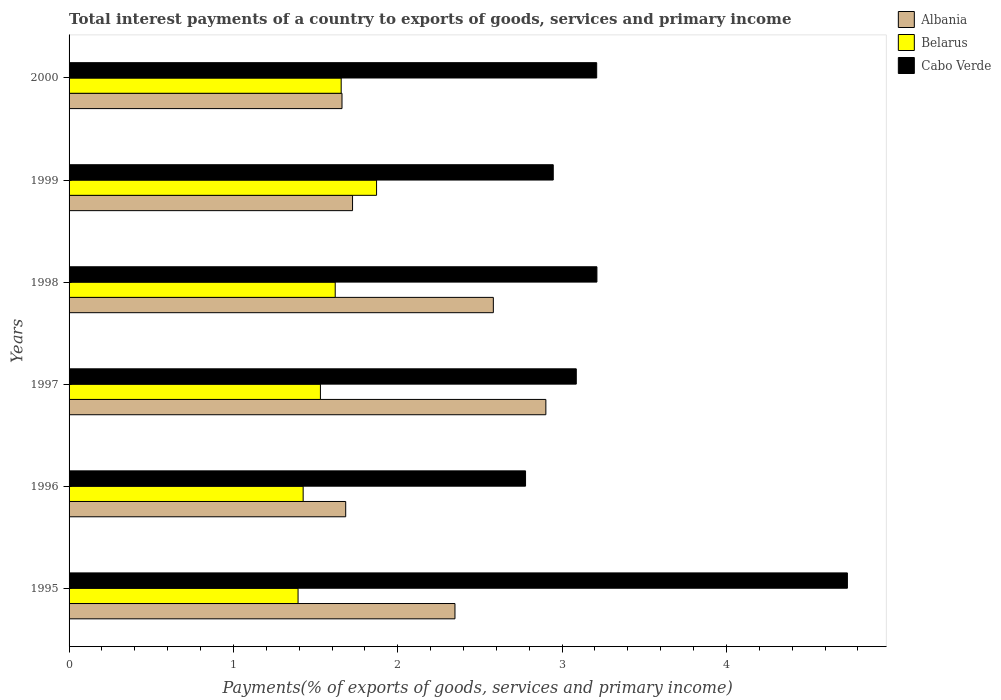How many groups of bars are there?
Your answer should be compact. 6. Are the number of bars per tick equal to the number of legend labels?
Your answer should be compact. Yes. How many bars are there on the 2nd tick from the bottom?
Provide a succinct answer. 3. In how many cases, is the number of bars for a given year not equal to the number of legend labels?
Offer a very short reply. 0. What is the total interest payments in Cabo Verde in 1997?
Your answer should be compact. 3.09. Across all years, what is the maximum total interest payments in Belarus?
Ensure brevity in your answer.  1.87. Across all years, what is the minimum total interest payments in Albania?
Your answer should be very brief. 1.66. In which year was the total interest payments in Belarus maximum?
Offer a very short reply. 1999. In which year was the total interest payments in Albania minimum?
Provide a succinct answer. 2000. What is the total total interest payments in Belarus in the graph?
Give a very brief answer. 9.49. What is the difference between the total interest payments in Cabo Verde in 1995 and that in 1998?
Your response must be concise. 1.52. What is the difference between the total interest payments in Cabo Verde in 2000 and the total interest payments in Albania in 1999?
Offer a terse response. 1.49. What is the average total interest payments in Cabo Verde per year?
Offer a very short reply. 3.33. In the year 1998, what is the difference between the total interest payments in Cabo Verde and total interest payments in Belarus?
Provide a short and direct response. 1.59. What is the ratio of the total interest payments in Cabo Verde in 1996 to that in 1998?
Provide a succinct answer. 0.86. What is the difference between the highest and the second highest total interest payments in Belarus?
Your answer should be compact. 0.22. What is the difference between the highest and the lowest total interest payments in Cabo Verde?
Make the answer very short. 1.96. Is the sum of the total interest payments in Albania in 1996 and 1997 greater than the maximum total interest payments in Cabo Verde across all years?
Your response must be concise. No. What does the 3rd bar from the top in 1996 represents?
Make the answer very short. Albania. What does the 2nd bar from the bottom in 1997 represents?
Make the answer very short. Belarus. Is it the case that in every year, the sum of the total interest payments in Belarus and total interest payments in Cabo Verde is greater than the total interest payments in Albania?
Make the answer very short. Yes. How many years are there in the graph?
Ensure brevity in your answer.  6. What is the difference between two consecutive major ticks on the X-axis?
Offer a very short reply. 1. Are the values on the major ticks of X-axis written in scientific E-notation?
Your answer should be very brief. No. Does the graph contain any zero values?
Your answer should be very brief. No. How many legend labels are there?
Provide a short and direct response. 3. How are the legend labels stacked?
Ensure brevity in your answer.  Vertical. What is the title of the graph?
Make the answer very short. Total interest payments of a country to exports of goods, services and primary income. Does "Nigeria" appear as one of the legend labels in the graph?
Your answer should be very brief. No. What is the label or title of the X-axis?
Provide a succinct answer. Payments(% of exports of goods, services and primary income). What is the label or title of the Y-axis?
Provide a succinct answer. Years. What is the Payments(% of exports of goods, services and primary income) in Albania in 1995?
Give a very brief answer. 2.35. What is the Payments(% of exports of goods, services and primary income) of Belarus in 1995?
Your response must be concise. 1.39. What is the Payments(% of exports of goods, services and primary income) in Cabo Verde in 1995?
Ensure brevity in your answer.  4.74. What is the Payments(% of exports of goods, services and primary income) of Albania in 1996?
Provide a succinct answer. 1.68. What is the Payments(% of exports of goods, services and primary income) of Belarus in 1996?
Provide a succinct answer. 1.42. What is the Payments(% of exports of goods, services and primary income) in Cabo Verde in 1996?
Offer a very short reply. 2.78. What is the Payments(% of exports of goods, services and primary income) in Albania in 1997?
Offer a very short reply. 2.9. What is the Payments(% of exports of goods, services and primary income) in Belarus in 1997?
Offer a terse response. 1.53. What is the Payments(% of exports of goods, services and primary income) of Cabo Verde in 1997?
Offer a very short reply. 3.09. What is the Payments(% of exports of goods, services and primary income) of Albania in 1998?
Your answer should be compact. 2.58. What is the Payments(% of exports of goods, services and primary income) in Belarus in 1998?
Keep it short and to the point. 1.62. What is the Payments(% of exports of goods, services and primary income) in Cabo Verde in 1998?
Your response must be concise. 3.21. What is the Payments(% of exports of goods, services and primary income) of Albania in 1999?
Provide a short and direct response. 1.72. What is the Payments(% of exports of goods, services and primary income) of Belarus in 1999?
Ensure brevity in your answer.  1.87. What is the Payments(% of exports of goods, services and primary income) of Cabo Verde in 1999?
Keep it short and to the point. 2.95. What is the Payments(% of exports of goods, services and primary income) in Albania in 2000?
Your answer should be compact. 1.66. What is the Payments(% of exports of goods, services and primary income) in Belarus in 2000?
Offer a terse response. 1.66. What is the Payments(% of exports of goods, services and primary income) of Cabo Verde in 2000?
Your answer should be very brief. 3.21. Across all years, what is the maximum Payments(% of exports of goods, services and primary income) in Albania?
Your answer should be very brief. 2.9. Across all years, what is the maximum Payments(% of exports of goods, services and primary income) in Belarus?
Ensure brevity in your answer.  1.87. Across all years, what is the maximum Payments(% of exports of goods, services and primary income) in Cabo Verde?
Offer a very short reply. 4.74. Across all years, what is the minimum Payments(% of exports of goods, services and primary income) of Albania?
Ensure brevity in your answer.  1.66. Across all years, what is the minimum Payments(% of exports of goods, services and primary income) of Belarus?
Offer a very short reply. 1.39. Across all years, what is the minimum Payments(% of exports of goods, services and primary income) of Cabo Verde?
Offer a very short reply. 2.78. What is the total Payments(% of exports of goods, services and primary income) of Belarus in the graph?
Offer a very short reply. 9.49. What is the total Payments(% of exports of goods, services and primary income) in Cabo Verde in the graph?
Your answer should be compact. 19.97. What is the difference between the Payments(% of exports of goods, services and primary income) of Albania in 1995 and that in 1996?
Give a very brief answer. 0.66. What is the difference between the Payments(% of exports of goods, services and primary income) of Belarus in 1995 and that in 1996?
Ensure brevity in your answer.  -0.03. What is the difference between the Payments(% of exports of goods, services and primary income) of Cabo Verde in 1995 and that in 1996?
Provide a succinct answer. 1.96. What is the difference between the Payments(% of exports of goods, services and primary income) in Albania in 1995 and that in 1997?
Your answer should be compact. -0.55. What is the difference between the Payments(% of exports of goods, services and primary income) in Belarus in 1995 and that in 1997?
Keep it short and to the point. -0.14. What is the difference between the Payments(% of exports of goods, services and primary income) of Cabo Verde in 1995 and that in 1997?
Your answer should be very brief. 1.65. What is the difference between the Payments(% of exports of goods, services and primary income) in Albania in 1995 and that in 1998?
Offer a terse response. -0.23. What is the difference between the Payments(% of exports of goods, services and primary income) in Belarus in 1995 and that in 1998?
Keep it short and to the point. -0.23. What is the difference between the Payments(% of exports of goods, services and primary income) of Cabo Verde in 1995 and that in 1998?
Offer a terse response. 1.52. What is the difference between the Payments(% of exports of goods, services and primary income) in Albania in 1995 and that in 1999?
Your answer should be compact. 0.62. What is the difference between the Payments(% of exports of goods, services and primary income) in Belarus in 1995 and that in 1999?
Your answer should be compact. -0.48. What is the difference between the Payments(% of exports of goods, services and primary income) of Cabo Verde in 1995 and that in 1999?
Ensure brevity in your answer.  1.79. What is the difference between the Payments(% of exports of goods, services and primary income) in Albania in 1995 and that in 2000?
Keep it short and to the point. 0.69. What is the difference between the Payments(% of exports of goods, services and primary income) in Belarus in 1995 and that in 2000?
Provide a succinct answer. -0.26. What is the difference between the Payments(% of exports of goods, services and primary income) of Cabo Verde in 1995 and that in 2000?
Your answer should be compact. 1.53. What is the difference between the Payments(% of exports of goods, services and primary income) of Albania in 1996 and that in 1997?
Your answer should be compact. -1.22. What is the difference between the Payments(% of exports of goods, services and primary income) in Belarus in 1996 and that in 1997?
Your answer should be compact. -0.11. What is the difference between the Payments(% of exports of goods, services and primary income) in Cabo Verde in 1996 and that in 1997?
Provide a short and direct response. -0.31. What is the difference between the Payments(% of exports of goods, services and primary income) of Albania in 1996 and that in 1998?
Your answer should be very brief. -0.9. What is the difference between the Payments(% of exports of goods, services and primary income) in Belarus in 1996 and that in 1998?
Give a very brief answer. -0.2. What is the difference between the Payments(% of exports of goods, services and primary income) of Cabo Verde in 1996 and that in 1998?
Offer a terse response. -0.43. What is the difference between the Payments(% of exports of goods, services and primary income) of Albania in 1996 and that in 1999?
Provide a short and direct response. -0.04. What is the difference between the Payments(% of exports of goods, services and primary income) in Belarus in 1996 and that in 1999?
Keep it short and to the point. -0.45. What is the difference between the Payments(% of exports of goods, services and primary income) of Cabo Verde in 1996 and that in 1999?
Make the answer very short. -0.17. What is the difference between the Payments(% of exports of goods, services and primary income) in Albania in 1996 and that in 2000?
Give a very brief answer. 0.02. What is the difference between the Payments(% of exports of goods, services and primary income) in Belarus in 1996 and that in 2000?
Ensure brevity in your answer.  -0.23. What is the difference between the Payments(% of exports of goods, services and primary income) of Cabo Verde in 1996 and that in 2000?
Offer a very short reply. -0.43. What is the difference between the Payments(% of exports of goods, services and primary income) in Albania in 1997 and that in 1998?
Provide a short and direct response. 0.32. What is the difference between the Payments(% of exports of goods, services and primary income) in Belarus in 1997 and that in 1998?
Make the answer very short. -0.09. What is the difference between the Payments(% of exports of goods, services and primary income) of Cabo Verde in 1997 and that in 1998?
Provide a succinct answer. -0.13. What is the difference between the Payments(% of exports of goods, services and primary income) in Albania in 1997 and that in 1999?
Give a very brief answer. 1.18. What is the difference between the Payments(% of exports of goods, services and primary income) in Belarus in 1997 and that in 1999?
Provide a short and direct response. -0.34. What is the difference between the Payments(% of exports of goods, services and primary income) in Cabo Verde in 1997 and that in 1999?
Your answer should be very brief. 0.14. What is the difference between the Payments(% of exports of goods, services and primary income) of Albania in 1997 and that in 2000?
Make the answer very short. 1.24. What is the difference between the Payments(% of exports of goods, services and primary income) in Belarus in 1997 and that in 2000?
Provide a succinct answer. -0.13. What is the difference between the Payments(% of exports of goods, services and primary income) in Cabo Verde in 1997 and that in 2000?
Give a very brief answer. -0.12. What is the difference between the Payments(% of exports of goods, services and primary income) of Albania in 1998 and that in 1999?
Offer a very short reply. 0.86. What is the difference between the Payments(% of exports of goods, services and primary income) of Belarus in 1998 and that in 1999?
Ensure brevity in your answer.  -0.25. What is the difference between the Payments(% of exports of goods, services and primary income) in Cabo Verde in 1998 and that in 1999?
Your answer should be compact. 0.27. What is the difference between the Payments(% of exports of goods, services and primary income) of Albania in 1998 and that in 2000?
Your answer should be very brief. 0.92. What is the difference between the Payments(% of exports of goods, services and primary income) of Belarus in 1998 and that in 2000?
Offer a terse response. -0.04. What is the difference between the Payments(% of exports of goods, services and primary income) in Cabo Verde in 1998 and that in 2000?
Offer a terse response. 0. What is the difference between the Payments(% of exports of goods, services and primary income) of Albania in 1999 and that in 2000?
Provide a succinct answer. 0.06. What is the difference between the Payments(% of exports of goods, services and primary income) in Belarus in 1999 and that in 2000?
Give a very brief answer. 0.22. What is the difference between the Payments(% of exports of goods, services and primary income) of Cabo Verde in 1999 and that in 2000?
Your answer should be very brief. -0.26. What is the difference between the Payments(% of exports of goods, services and primary income) in Albania in 1995 and the Payments(% of exports of goods, services and primary income) in Belarus in 1996?
Offer a terse response. 0.92. What is the difference between the Payments(% of exports of goods, services and primary income) of Albania in 1995 and the Payments(% of exports of goods, services and primary income) of Cabo Verde in 1996?
Offer a very short reply. -0.43. What is the difference between the Payments(% of exports of goods, services and primary income) in Belarus in 1995 and the Payments(% of exports of goods, services and primary income) in Cabo Verde in 1996?
Provide a succinct answer. -1.38. What is the difference between the Payments(% of exports of goods, services and primary income) of Albania in 1995 and the Payments(% of exports of goods, services and primary income) of Belarus in 1997?
Keep it short and to the point. 0.82. What is the difference between the Payments(% of exports of goods, services and primary income) of Albania in 1995 and the Payments(% of exports of goods, services and primary income) of Cabo Verde in 1997?
Offer a terse response. -0.74. What is the difference between the Payments(% of exports of goods, services and primary income) of Belarus in 1995 and the Payments(% of exports of goods, services and primary income) of Cabo Verde in 1997?
Offer a terse response. -1.69. What is the difference between the Payments(% of exports of goods, services and primary income) of Albania in 1995 and the Payments(% of exports of goods, services and primary income) of Belarus in 1998?
Offer a terse response. 0.73. What is the difference between the Payments(% of exports of goods, services and primary income) of Albania in 1995 and the Payments(% of exports of goods, services and primary income) of Cabo Verde in 1998?
Provide a short and direct response. -0.86. What is the difference between the Payments(% of exports of goods, services and primary income) in Belarus in 1995 and the Payments(% of exports of goods, services and primary income) in Cabo Verde in 1998?
Offer a very short reply. -1.82. What is the difference between the Payments(% of exports of goods, services and primary income) of Albania in 1995 and the Payments(% of exports of goods, services and primary income) of Belarus in 1999?
Your answer should be compact. 0.48. What is the difference between the Payments(% of exports of goods, services and primary income) of Albania in 1995 and the Payments(% of exports of goods, services and primary income) of Cabo Verde in 1999?
Provide a succinct answer. -0.6. What is the difference between the Payments(% of exports of goods, services and primary income) in Belarus in 1995 and the Payments(% of exports of goods, services and primary income) in Cabo Verde in 1999?
Offer a terse response. -1.55. What is the difference between the Payments(% of exports of goods, services and primary income) in Albania in 1995 and the Payments(% of exports of goods, services and primary income) in Belarus in 2000?
Provide a succinct answer. 0.69. What is the difference between the Payments(% of exports of goods, services and primary income) of Albania in 1995 and the Payments(% of exports of goods, services and primary income) of Cabo Verde in 2000?
Provide a succinct answer. -0.86. What is the difference between the Payments(% of exports of goods, services and primary income) in Belarus in 1995 and the Payments(% of exports of goods, services and primary income) in Cabo Verde in 2000?
Ensure brevity in your answer.  -1.82. What is the difference between the Payments(% of exports of goods, services and primary income) of Albania in 1996 and the Payments(% of exports of goods, services and primary income) of Belarus in 1997?
Make the answer very short. 0.15. What is the difference between the Payments(% of exports of goods, services and primary income) in Albania in 1996 and the Payments(% of exports of goods, services and primary income) in Cabo Verde in 1997?
Provide a succinct answer. -1.4. What is the difference between the Payments(% of exports of goods, services and primary income) of Belarus in 1996 and the Payments(% of exports of goods, services and primary income) of Cabo Verde in 1997?
Offer a very short reply. -1.66. What is the difference between the Payments(% of exports of goods, services and primary income) of Albania in 1996 and the Payments(% of exports of goods, services and primary income) of Belarus in 1998?
Make the answer very short. 0.06. What is the difference between the Payments(% of exports of goods, services and primary income) of Albania in 1996 and the Payments(% of exports of goods, services and primary income) of Cabo Verde in 1998?
Provide a succinct answer. -1.53. What is the difference between the Payments(% of exports of goods, services and primary income) of Belarus in 1996 and the Payments(% of exports of goods, services and primary income) of Cabo Verde in 1998?
Provide a short and direct response. -1.79. What is the difference between the Payments(% of exports of goods, services and primary income) in Albania in 1996 and the Payments(% of exports of goods, services and primary income) in Belarus in 1999?
Offer a very short reply. -0.19. What is the difference between the Payments(% of exports of goods, services and primary income) of Albania in 1996 and the Payments(% of exports of goods, services and primary income) of Cabo Verde in 1999?
Provide a succinct answer. -1.26. What is the difference between the Payments(% of exports of goods, services and primary income) in Belarus in 1996 and the Payments(% of exports of goods, services and primary income) in Cabo Verde in 1999?
Ensure brevity in your answer.  -1.52. What is the difference between the Payments(% of exports of goods, services and primary income) of Albania in 1996 and the Payments(% of exports of goods, services and primary income) of Belarus in 2000?
Your answer should be very brief. 0.03. What is the difference between the Payments(% of exports of goods, services and primary income) in Albania in 1996 and the Payments(% of exports of goods, services and primary income) in Cabo Verde in 2000?
Keep it short and to the point. -1.53. What is the difference between the Payments(% of exports of goods, services and primary income) of Belarus in 1996 and the Payments(% of exports of goods, services and primary income) of Cabo Verde in 2000?
Your response must be concise. -1.79. What is the difference between the Payments(% of exports of goods, services and primary income) of Albania in 1997 and the Payments(% of exports of goods, services and primary income) of Belarus in 1998?
Your response must be concise. 1.28. What is the difference between the Payments(% of exports of goods, services and primary income) of Albania in 1997 and the Payments(% of exports of goods, services and primary income) of Cabo Verde in 1998?
Ensure brevity in your answer.  -0.31. What is the difference between the Payments(% of exports of goods, services and primary income) of Belarus in 1997 and the Payments(% of exports of goods, services and primary income) of Cabo Verde in 1998?
Give a very brief answer. -1.68. What is the difference between the Payments(% of exports of goods, services and primary income) in Albania in 1997 and the Payments(% of exports of goods, services and primary income) in Belarus in 1999?
Your response must be concise. 1.03. What is the difference between the Payments(% of exports of goods, services and primary income) of Albania in 1997 and the Payments(% of exports of goods, services and primary income) of Cabo Verde in 1999?
Provide a short and direct response. -0.04. What is the difference between the Payments(% of exports of goods, services and primary income) in Belarus in 1997 and the Payments(% of exports of goods, services and primary income) in Cabo Verde in 1999?
Ensure brevity in your answer.  -1.42. What is the difference between the Payments(% of exports of goods, services and primary income) of Albania in 1997 and the Payments(% of exports of goods, services and primary income) of Belarus in 2000?
Provide a short and direct response. 1.25. What is the difference between the Payments(% of exports of goods, services and primary income) in Albania in 1997 and the Payments(% of exports of goods, services and primary income) in Cabo Verde in 2000?
Offer a terse response. -0.31. What is the difference between the Payments(% of exports of goods, services and primary income) in Belarus in 1997 and the Payments(% of exports of goods, services and primary income) in Cabo Verde in 2000?
Keep it short and to the point. -1.68. What is the difference between the Payments(% of exports of goods, services and primary income) in Albania in 1998 and the Payments(% of exports of goods, services and primary income) in Belarus in 1999?
Provide a succinct answer. 0.71. What is the difference between the Payments(% of exports of goods, services and primary income) in Albania in 1998 and the Payments(% of exports of goods, services and primary income) in Cabo Verde in 1999?
Provide a succinct answer. -0.36. What is the difference between the Payments(% of exports of goods, services and primary income) in Belarus in 1998 and the Payments(% of exports of goods, services and primary income) in Cabo Verde in 1999?
Your response must be concise. -1.33. What is the difference between the Payments(% of exports of goods, services and primary income) of Albania in 1998 and the Payments(% of exports of goods, services and primary income) of Belarus in 2000?
Your answer should be compact. 0.93. What is the difference between the Payments(% of exports of goods, services and primary income) of Albania in 1998 and the Payments(% of exports of goods, services and primary income) of Cabo Verde in 2000?
Keep it short and to the point. -0.63. What is the difference between the Payments(% of exports of goods, services and primary income) of Belarus in 1998 and the Payments(% of exports of goods, services and primary income) of Cabo Verde in 2000?
Provide a succinct answer. -1.59. What is the difference between the Payments(% of exports of goods, services and primary income) in Albania in 1999 and the Payments(% of exports of goods, services and primary income) in Belarus in 2000?
Provide a succinct answer. 0.07. What is the difference between the Payments(% of exports of goods, services and primary income) of Albania in 1999 and the Payments(% of exports of goods, services and primary income) of Cabo Verde in 2000?
Offer a very short reply. -1.49. What is the difference between the Payments(% of exports of goods, services and primary income) of Belarus in 1999 and the Payments(% of exports of goods, services and primary income) of Cabo Verde in 2000?
Offer a very short reply. -1.34. What is the average Payments(% of exports of goods, services and primary income) in Albania per year?
Offer a very short reply. 2.15. What is the average Payments(% of exports of goods, services and primary income) in Belarus per year?
Offer a terse response. 1.58. What is the average Payments(% of exports of goods, services and primary income) in Cabo Verde per year?
Ensure brevity in your answer.  3.33. In the year 1995, what is the difference between the Payments(% of exports of goods, services and primary income) in Albania and Payments(% of exports of goods, services and primary income) in Belarus?
Provide a short and direct response. 0.95. In the year 1995, what is the difference between the Payments(% of exports of goods, services and primary income) in Albania and Payments(% of exports of goods, services and primary income) in Cabo Verde?
Ensure brevity in your answer.  -2.39. In the year 1995, what is the difference between the Payments(% of exports of goods, services and primary income) of Belarus and Payments(% of exports of goods, services and primary income) of Cabo Verde?
Make the answer very short. -3.34. In the year 1996, what is the difference between the Payments(% of exports of goods, services and primary income) in Albania and Payments(% of exports of goods, services and primary income) in Belarus?
Offer a terse response. 0.26. In the year 1996, what is the difference between the Payments(% of exports of goods, services and primary income) in Albania and Payments(% of exports of goods, services and primary income) in Cabo Verde?
Your response must be concise. -1.09. In the year 1996, what is the difference between the Payments(% of exports of goods, services and primary income) of Belarus and Payments(% of exports of goods, services and primary income) of Cabo Verde?
Offer a terse response. -1.35. In the year 1997, what is the difference between the Payments(% of exports of goods, services and primary income) in Albania and Payments(% of exports of goods, services and primary income) in Belarus?
Give a very brief answer. 1.37. In the year 1997, what is the difference between the Payments(% of exports of goods, services and primary income) of Albania and Payments(% of exports of goods, services and primary income) of Cabo Verde?
Your answer should be compact. -0.19. In the year 1997, what is the difference between the Payments(% of exports of goods, services and primary income) in Belarus and Payments(% of exports of goods, services and primary income) in Cabo Verde?
Ensure brevity in your answer.  -1.56. In the year 1998, what is the difference between the Payments(% of exports of goods, services and primary income) in Albania and Payments(% of exports of goods, services and primary income) in Belarus?
Keep it short and to the point. 0.96. In the year 1998, what is the difference between the Payments(% of exports of goods, services and primary income) in Albania and Payments(% of exports of goods, services and primary income) in Cabo Verde?
Make the answer very short. -0.63. In the year 1998, what is the difference between the Payments(% of exports of goods, services and primary income) of Belarus and Payments(% of exports of goods, services and primary income) of Cabo Verde?
Keep it short and to the point. -1.59. In the year 1999, what is the difference between the Payments(% of exports of goods, services and primary income) of Albania and Payments(% of exports of goods, services and primary income) of Belarus?
Give a very brief answer. -0.15. In the year 1999, what is the difference between the Payments(% of exports of goods, services and primary income) of Albania and Payments(% of exports of goods, services and primary income) of Cabo Verde?
Offer a very short reply. -1.22. In the year 1999, what is the difference between the Payments(% of exports of goods, services and primary income) of Belarus and Payments(% of exports of goods, services and primary income) of Cabo Verde?
Make the answer very short. -1.08. In the year 2000, what is the difference between the Payments(% of exports of goods, services and primary income) of Albania and Payments(% of exports of goods, services and primary income) of Belarus?
Provide a succinct answer. 0. In the year 2000, what is the difference between the Payments(% of exports of goods, services and primary income) of Albania and Payments(% of exports of goods, services and primary income) of Cabo Verde?
Provide a succinct answer. -1.55. In the year 2000, what is the difference between the Payments(% of exports of goods, services and primary income) of Belarus and Payments(% of exports of goods, services and primary income) of Cabo Verde?
Your answer should be very brief. -1.55. What is the ratio of the Payments(% of exports of goods, services and primary income) of Albania in 1995 to that in 1996?
Make the answer very short. 1.4. What is the ratio of the Payments(% of exports of goods, services and primary income) in Belarus in 1995 to that in 1996?
Provide a short and direct response. 0.98. What is the ratio of the Payments(% of exports of goods, services and primary income) in Cabo Verde in 1995 to that in 1996?
Provide a succinct answer. 1.71. What is the ratio of the Payments(% of exports of goods, services and primary income) of Albania in 1995 to that in 1997?
Your answer should be compact. 0.81. What is the ratio of the Payments(% of exports of goods, services and primary income) in Belarus in 1995 to that in 1997?
Your answer should be compact. 0.91. What is the ratio of the Payments(% of exports of goods, services and primary income) in Cabo Verde in 1995 to that in 1997?
Ensure brevity in your answer.  1.53. What is the ratio of the Payments(% of exports of goods, services and primary income) in Albania in 1995 to that in 1998?
Offer a terse response. 0.91. What is the ratio of the Payments(% of exports of goods, services and primary income) of Belarus in 1995 to that in 1998?
Keep it short and to the point. 0.86. What is the ratio of the Payments(% of exports of goods, services and primary income) in Cabo Verde in 1995 to that in 1998?
Offer a terse response. 1.47. What is the ratio of the Payments(% of exports of goods, services and primary income) in Albania in 1995 to that in 1999?
Ensure brevity in your answer.  1.36. What is the ratio of the Payments(% of exports of goods, services and primary income) of Belarus in 1995 to that in 1999?
Ensure brevity in your answer.  0.74. What is the ratio of the Payments(% of exports of goods, services and primary income) in Cabo Verde in 1995 to that in 1999?
Provide a short and direct response. 1.61. What is the ratio of the Payments(% of exports of goods, services and primary income) of Albania in 1995 to that in 2000?
Provide a short and direct response. 1.41. What is the ratio of the Payments(% of exports of goods, services and primary income) in Belarus in 1995 to that in 2000?
Your answer should be very brief. 0.84. What is the ratio of the Payments(% of exports of goods, services and primary income) of Cabo Verde in 1995 to that in 2000?
Your answer should be compact. 1.48. What is the ratio of the Payments(% of exports of goods, services and primary income) of Albania in 1996 to that in 1997?
Your answer should be compact. 0.58. What is the ratio of the Payments(% of exports of goods, services and primary income) in Belarus in 1996 to that in 1997?
Give a very brief answer. 0.93. What is the ratio of the Payments(% of exports of goods, services and primary income) of Cabo Verde in 1996 to that in 1997?
Make the answer very short. 0.9. What is the ratio of the Payments(% of exports of goods, services and primary income) in Albania in 1996 to that in 1998?
Give a very brief answer. 0.65. What is the ratio of the Payments(% of exports of goods, services and primary income) in Belarus in 1996 to that in 1998?
Offer a very short reply. 0.88. What is the ratio of the Payments(% of exports of goods, services and primary income) of Cabo Verde in 1996 to that in 1998?
Give a very brief answer. 0.86. What is the ratio of the Payments(% of exports of goods, services and primary income) of Albania in 1996 to that in 1999?
Your answer should be compact. 0.98. What is the ratio of the Payments(% of exports of goods, services and primary income) in Belarus in 1996 to that in 1999?
Your response must be concise. 0.76. What is the ratio of the Payments(% of exports of goods, services and primary income) in Cabo Verde in 1996 to that in 1999?
Your answer should be compact. 0.94. What is the ratio of the Payments(% of exports of goods, services and primary income) of Albania in 1996 to that in 2000?
Offer a very short reply. 1.01. What is the ratio of the Payments(% of exports of goods, services and primary income) in Belarus in 1996 to that in 2000?
Your answer should be compact. 0.86. What is the ratio of the Payments(% of exports of goods, services and primary income) in Cabo Verde in 1996 to that in 2000?
Offer a very short reply. 0.87. What is the ratio of the Payments(% of exports of goods, services and primary income) in Albania in 1997 to that in 1998?
Provide a succinct answer. 1.12. What is the ratio of the Payments(% of exports of goods, services and primary income) of Belarus in 1997 to that in 1998?
Keep it short and to the point. 0.94. What is the ratio of the Payments(% of exports of goods, services and primary income) of Cabo Verde in 1997 to that in 1998?
Give a very brief answer. 0.96. What is the ratio of the Payments(% of exports of goods, services and primary income) of Albania in 1997 to that in 1999?
Keep it short and to the point. 1.68. What is the ratio of the Payments(% of exports of goods, services and primary income) in Belarus in 1997 to that in 1999?
Offer a terse response. 0.82. What is the ratio of the Payments(% of exports of goods, services and primary income) of Cabo Verde in 1997 to that in 1999?
Keep it short and to the point. 1.05. What is the ratio of the Payments(% of exports of goods, services and primary income) in Albania in 1997 to that in 2000?
Keep it short and to the point. 1.75. What is the ratio of the Payments(% of exports of goods, services and primary income) of Belarus in 1997 to that in 2000?
Your answer should be very brief. 0.92. What is the ratio of the Payments(% of exports of goods, services and primary income) of Cabo Verde in 1997 to that in 2000?
Provide a succinct answer. 0.96. What is the ratio of the Payments(% of exports of goods, services and primary income) in Albania in 1998 to that in 1999?
Your answer should be compact. 1.5. What is the ratio of the Payments(% of exports of goods, services and primary income) in Belarus in 1998 to that in 1999?
Make the answer very short. 0.87. What is the ratio of the Payments(% of exports of goods, services and primary income) of Cabo Verde in 1998 to that in 1999?
Offer a terse response. 1.09. What is the ratio of the Payments(% of exports of goods, services and primary income) in Albania in 1998 to that in 2000?
Ensure brevity in your answer.  1.55. What is the ratio of the Payments(% of exports of goods, services and primary income) in Belarus in 1998 to that in 2000?
Provide a succinct answer. 0.98. What is the ratio of the Payments(% of exports of goods, services and primary income) of Cabo Verde in 1998 to that in 2000?
Give a very brief answer. 1. What is the ratio of the Payments(% of exports of goods, services and primary income) of Albania in 1999 to that in 2000?
Provide a succinct answer. 1.04. What is the ratio of the Payments(% of exports of goods, services and primary income) in Belarus in 1999 to that in 2000?
Offer a very short reply. 1.13. What is the ratio of the Payments(% of exports of goods, services and primary income) of Cabo Verde in 1999 to that in 2000?
Give a very brief answer. 0.92. What is the difference between the highest and the second highest Payments(% of exports of goods, services and primary income) in Albania?
Ensure brevity in your answer.  0.32. What is the difference between the highest and the second highest Payments(% of exports of goods, services and primary income) in Belarus?
Ensure brevity in your answer.  0.22. What is the difference between the highest and the second highest Payments(% of exports of goods, services and primary income) in Cabo Verde?
Your answer should be very brief. 1.52. What is the difference between the highest and the lowest Payments(% of exports of goods, services and primary income) in Albania?
Your answer should be very brief. 1.24. What is the difference between the highest and the lowest Payments(% of exports of goods, services and primary income) of Belarus?
Give a very brief answer. 0.48. What is the difference between the highest and the lowest Payments(% of exports of goods, services and primary income) in Cabo Verde?
Your answer should be compact. 1.96. 